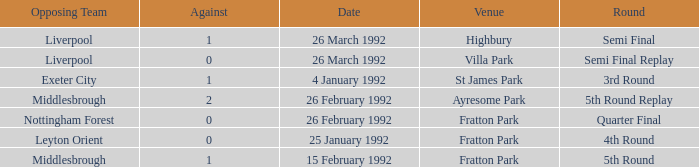What was the round for Villa Park? Semi Final Replay. 